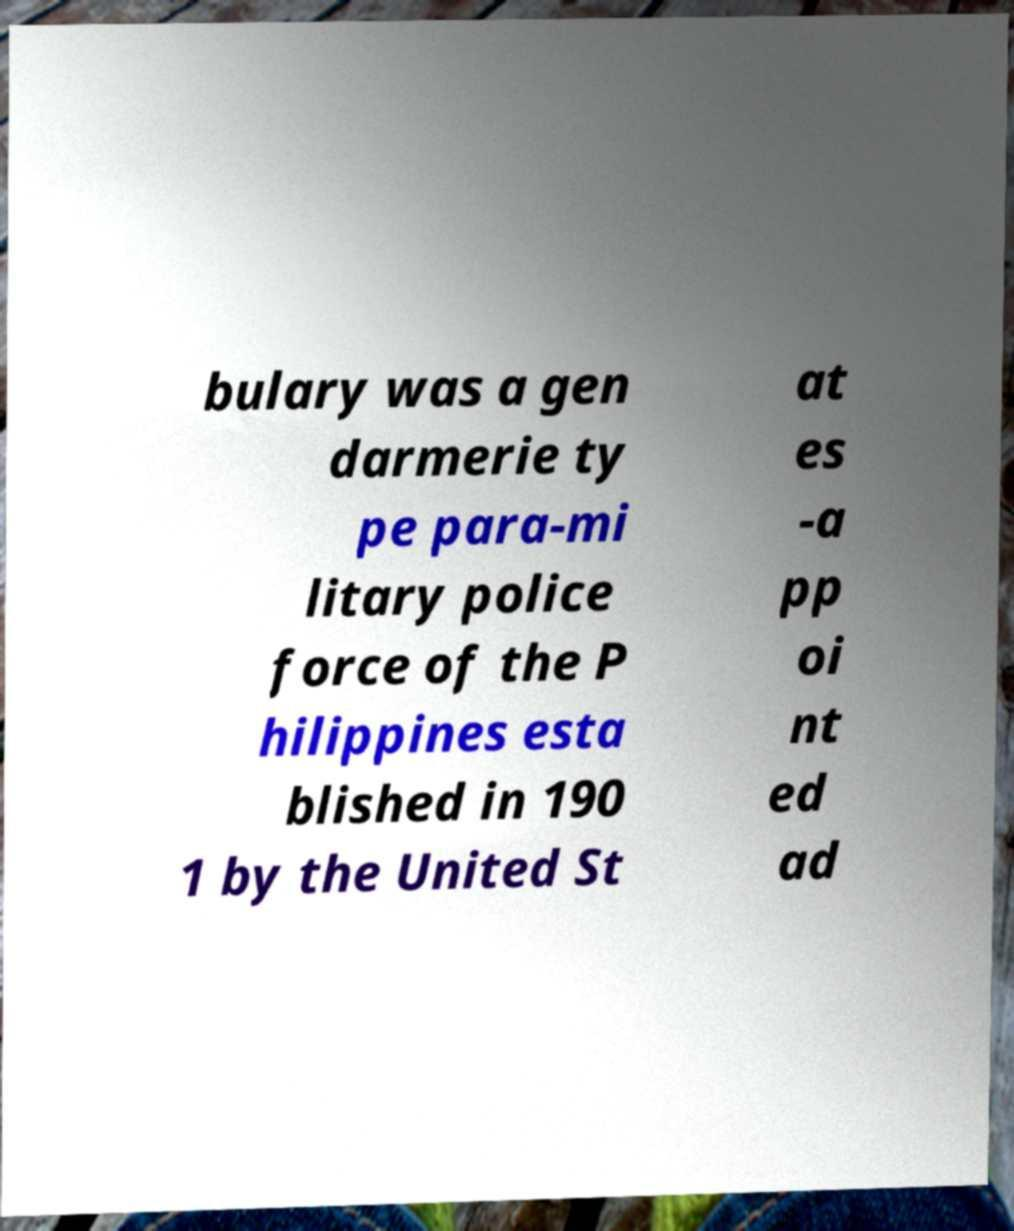For documentation purposes, I need the text within this image transcribed. Could you provide that? bulary was a gen darmerie ty pe para-mi litary police force of the P hilippines esta blished in 190 1 by the United St at es -a pp oi nt ed ad 